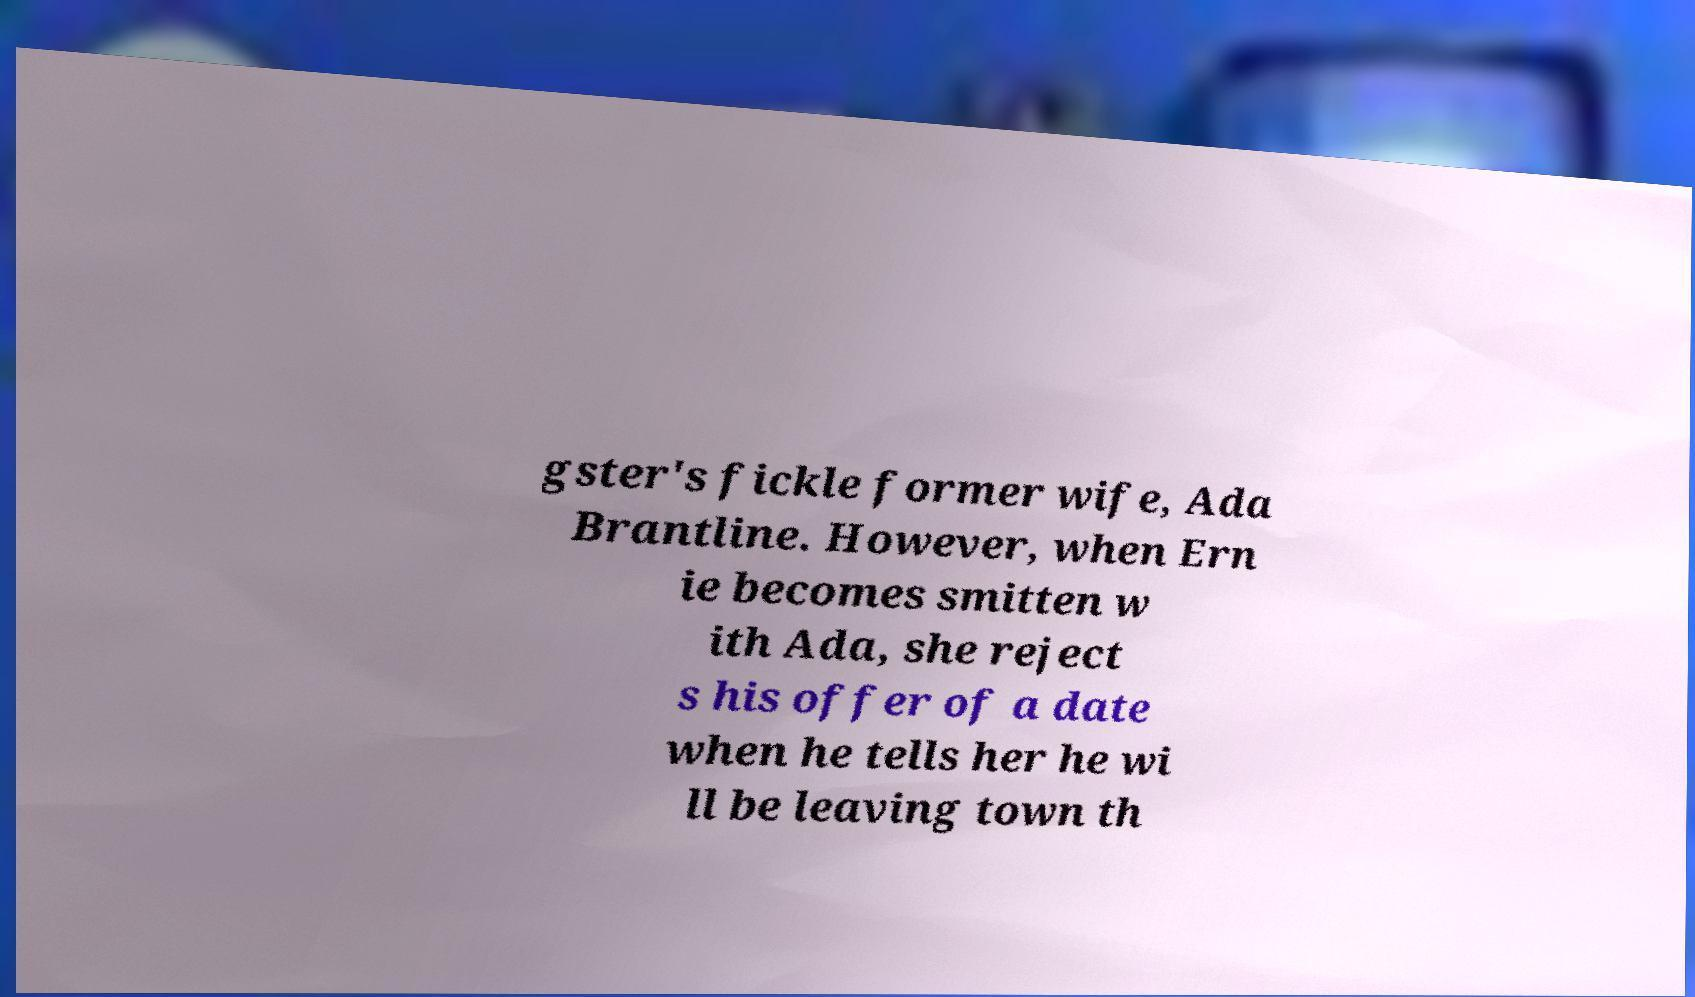Can you read and provide the text displayed in the image?This photo seems to have some interesting text. Can you extract and type it out for me? gster's fickle former wife, Ada Brantline. However, when Ern ie becomes smitten w ith Ada, she reject s his offer of a date when he tells her he wi ll be leaving town th 